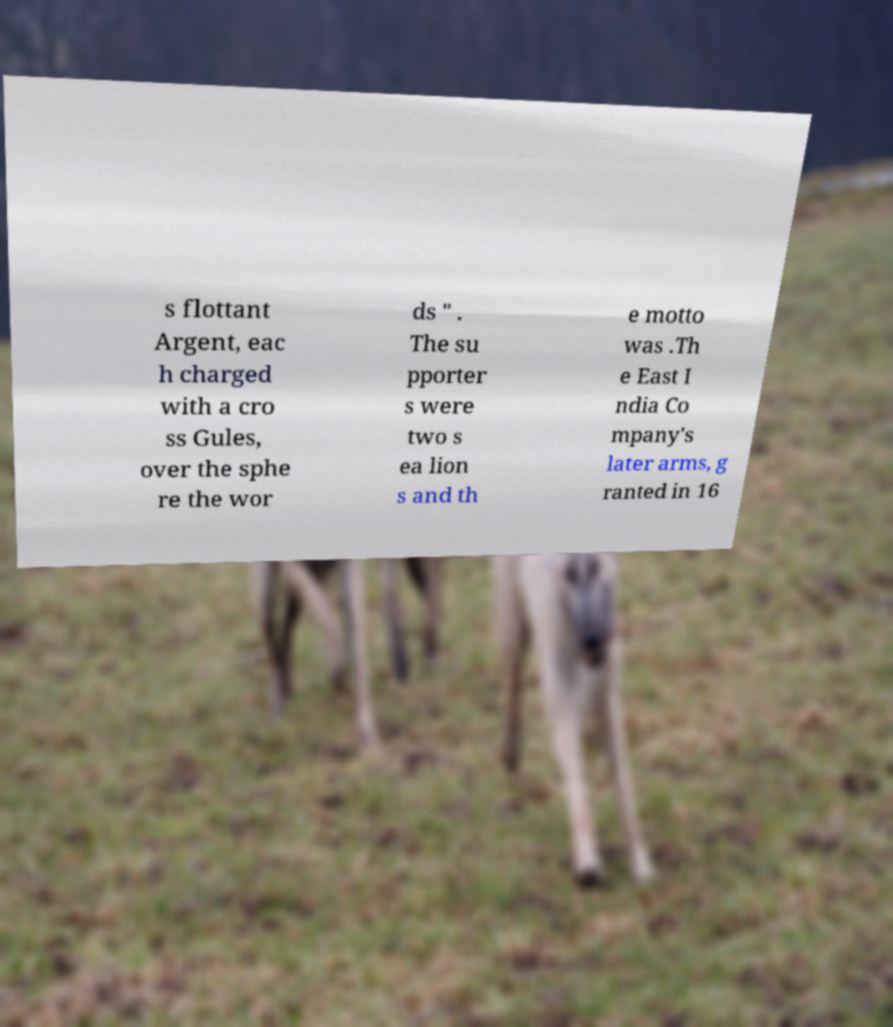Could you assist in decoding the text presented in this image and type it out clearly? s flottant Argent, eac h charged with a cro ss Gules, over the sphe re the wor ds " . The su pporter s were two s ea lion s and th e motto was .Th e East I ndia Co mpany's later arms, g ranted in 16 